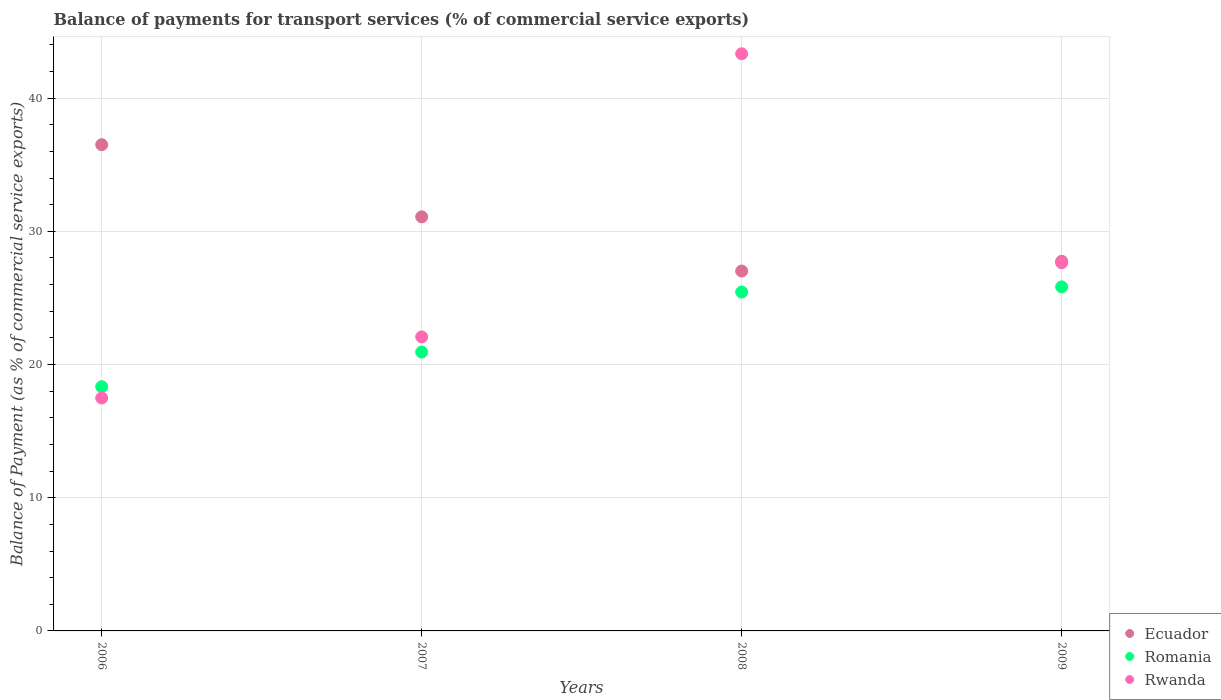Is the number of dotlines equal to the number of legend labels?
Offer a very short reply. Yes. What is the balance of payments for transport services in Rwanda in 2009?
Give a very brief answer. 27.64. Across all years, what is the maximum balance of payments for transport services in Rwanda?
Offer a very short reply. 43.33. Across all years, what is the minimum balance of payments for transport services in Ecuador?
Offer a very short reply. 27.02. What is the total balance of payments for transport services in Rwanda in the graph?
Provide a short and direct response. 110.54. What is the difference between the balance of payments for transport services in Romania in 2006 and that in 2009?
Offer a very short reply. -7.5. What is the difference between the balance of payments for transport services in Ecuador in 2006 and the balance of payments for transport services in Rwanda in 2007?
Your answer should be compact. 14.43. What is the average balance of payments for transport services in Rwanda per year?
Provide a succinct answer. 27.64. In the year 2008, what is the difference between the balance of payments for transport services in Rwanda and balance of payments for transport services in Romania?
Offer a very short reply. 17.89. In how many years, is the balance of payments for transport services in Rwanda greater than 24 %?
Your answer should be very brief. 2. What is the ratio of the balance of payments for transport services in Romania in 2007 to that in 2008?
Give a very brief answer. 0.82. Is the balance of payments for transport services in Rwanda in 2006 less than that in 2009?
Ensure brevity in your answer.  Yes. Is the difference between the balance of payments for transport services in Rwanda in 2008 and 2009 greater than the difference between the balance of payments for transport services in Romania in 2008 and 2009?
Make the answer very short. Yes. What is the difference between the highest and the second highest balance of payments for transport services in Romania?
Provide a short and direct response. 0.39. What is the difference between the highest and the lowest balance of payments for transport services in Rwanda?
Offer a very short reply. 25.84. Is the sum of the balance of payments for transport services in Rwanda in 2006 and 2007 greater than the maximum balance of payments for transport services in Romania across all years?
Provide a short and direct response. Yes. Is it the case that in every year, the sum of the balance of payments for transport services in Rwanda and balance of payments for transport services in Ecuador  is greater than the balance of payments for transport services in Romania?
Your answer should be compact. Yes. Does the balance of payments for transport services in Ecuador monotonically increase over the years?
Offer a very short reply. No. How many years are there in the graph?
Make the answer very short. 4. Are the values on the major ticks of Y-axis written in scientific E-notation?
Your answer should be very brief. No. Does the graph contain any zero values?
Your answer should be compact. No. Does the graph contain grids?
Offer a very short reply. Yes. How many legend labels are there?
Offer a very short reply. 3. What is the title of the graph?
Keep it short and to the point. Balance of payments for transport services (% of commercial service exports). What is the label or title of the X-axis?
Provide a short and direct response. Years. What is the label or title of the Y-axis?
Keep it short and to the point. Balance of Payment (as % of commercial service exports). What is the Balance of Payment (as % of commercial service exports) of Ecuador in 2006?
Your response must be concise. 36.51. What is the Balance of Payment (as % of commercial service exports) in Romania in 2006?
Your answer should be compact. 18.34. What is the Balance of Payment (as % of commercial service exports) in Rwanda in 2006?
Offer a very short reply. 17.49. What is the Balance of Payment (as % of commercial service exports) of Ecuador in 2007?
Provide a short and direct response. 31.09. What is the Balance of Payment (as % of commercial service exports) of Romania in 2007?
Ensure brevity in your answer.  20.94. What is the Balance of Payment (as % of commercial service exports) in Rwanda in 2007?
Your response must be concise. 22.08. What is the Balance of Payment (as % of commercial service exports) of Ecuador in 2008?
Provide a short and direct response. 27.02. What is the Balance of Payment (as % of commercial service exports) in Romania in 2008?
Offer a terse response. 25.44. What is the Balance of Payment (as % of commercial service exports) of Rwanda in 2008?
Provide a short and direct response. 43.33. What is the Balance of Payment (as % of commercial service exports) of Ecuador in 2009?
Your answer should be compact. 27.75. What is the Balance of Payment (as % of commercial service exports) of Romania in 2009?
Keep it short and to the point. 25.83. What is the Balance of Payment (as % of commercial service exports) of Rwanda in 2009?
Your answer should be very brief. 27.64. Across all years, what is the maximum Balance of Payment (as % of commercial service exports) in Ecuador?
Make the answer very short. 36.51. Across all years, what is the maximum Balance of Payment (as % of commercial service exports) of Romania?
Offer a terse response. 25.83. Across all years, what is the maximum Balance of Payment (as % of commercial service exports) of Rwanda?
Make the answer very short. 43.33. Across all years, what is the minimum Balance of Payment (as % of commercial service exports) in Ecuador?
Offer a very short reply. 27.02. Across all years, what is the minimum Balance of Payment (as % of commercial service exports) of Romania?
Your answer should be very brief. 18.34. Across all years, what is the minimum Balance of Payment (as % of commercial service exports) in Rwanda?
Ensure brevity in your answer.  17.49. What is the total Balance of Payment (as % of commercial service exports) in Ecuador in the graph?
Offer a very short reply. 122.37. What is the total Balance of Payment (as % of commercial service exports) in Romania in the graph?
Give a very brief answer. 90.55. What is the total Balance of Payment (as % of commercial service exports) in Rwanda in the graph?
Your answer should be compact. 110.54. What is the difference between the Balance of Payment (as % of commercial service exports) in Ecuador in 2006 and that in 2007?
Provide a succinct answer. 5.42. What is the difference between the Balance of Payment (as % of commercial service exports) in Romania in 2006 and that in 2007?
Offer a terse response. -2.6. What is the difference between the Balance of Payment (as % of commercial service exports) of Rwanda in 2006 and that in 2007?
Your response must be concise. -4.59. What is the difference between the Balance of Payment (as % of commercial service exports) of Ecuador in 2006 and that in 2008?
Your answer should be compact. 9.49. What is the difference between the Balance of Payment (as % of commercial service exports) in Romania in 2006 and that in 2008?
Your answer should be very brief. -7.11. What is the difference between the Balance of Payment (as % of commercial service exports) in Rwanda in 2006 and that in 2008?
Keep it short and to the point. -25.84. What is the difference between the Balance of Payment (as % of commercial service exports) of Ecuador in 2006 and that in 2009?
Your answer should be very brief. 8.76. What is the difference between the Balance of Payment (as % of commercial service exports) in Romania in 2006 and that in 2009?
Offer a very short reply. -7.5. What is the difference between the Balance of Payment (as % of commercial service exports) in Rwanda in 2006 and that in 2009?
Your answer should be very brief. -10.15. What is the difference between the Balance of Payment (as % of commercial service exports) of Ecuador in 2007 and that in 2008?
Keep it short and to the point. 4.07. What is the difference between the Balance of Payment (as % of commercial service exports) in Romania in 2007 and that in 2008?
Offer a terse response. -4.5. What is the difference between the Balance of Payment (as % of commercial service exports) of Rwanda in 2007 and that in 2008?
Your answer should be very brief. -21.26. What is the difference between the Balance of Payment (as % of commercial service exports) in Ecuador in 2007 and that in 2009?
Keep it short and to the point. 3.34. What is the difference between the Balance of Payment (as % of commercial service exports) of Romania in 2007 and that in 2009?
Keep it short and to the point. -4.9. What is the difference between the Balance of Payment (as % of commercial service exports) of Rwanda in 2007 and that in 2009?
Provide a short and direct response. -5.57. What is the difference between the Balance of Payment (as % of commercial service exports) of Ecuador in 2008 and that in 2009?
Offer a very short reply. -0.73. What is the difference between the Balance of Payment (as % of commercial service exports) in Romania in 2008 and that in 2009?
Provide a short and direct response. -0.39. What is the difference between the Balance of Payment (as % of commercial service exports) in Rwanda in 2008 and that in 2009?
Keep it short and to the point. 15.69. What is the difference between the Balance of Payment (as % of commercial service exports) of Ecuador in 2006 and the Balance of Payment (as % of commercial service exports) of Romania in 2007?
Your answer should be compact. 15.57. What is the difference between the Balance of Payment (as % of commercial service exports) in Ecuador in 2006 and the Balance of Payment (as % of commercial service exports) in Rwanda in 2007?
Offer a very short reply. 14.43. What is the difference between the Balance of Payment (as % of commercial service exports) in Romania in 2006 and the Balance of Payment (as % of commercial service exports) in Rwanda in 2007?
Offer a very short reply. -3.74. What is the difference between the Balance of Payment (as % of commercial service exports) of Ecuador in 2006 and the Balance of Payment (as % of commercial service exports) of Romania in 2008?
Offer a terse response. 11.07. What is the difference between the Balance of Payment (as % of commercial service exports) of Ecuador in 2006 and the Balance of Payment (as % of commercial service exports) of Rwanda in 2008?
Offer a terse response. -6.82. What is the difference between the Balance of Payment (as % of commercial service exports) of Romania in 2006 and the Balance of Payment (as % of commercial service exports) of Rwanda in 2008?
Your answer should be compact. -25. What is the difference between the Balance of Payment (as % of commercial service exports) in Ecuador in 2006 and the Balance of Payment (as % of commercial service exports) in Romania in 2009?
Ensure brevity in your answer.  10.67. What is the difference between the Balance of Payment (as % of commercial service exports) in Ecuador in 2006 and the Balance of Payment (as % of commercial service exports) in Rwanda in 2009?
Offer a terse response. 8.87. What is the difference between the Balance of Payment (as % of commercial service exports) in Romania in 2006 and the Balance of Payment (as % of commercial service exports) in Rwanda in 2009?
Keep it short and to the point. -9.31. What is the difference between the Balance of Payment (as % of commercial service exports) in Ecuador in 2007 and the Balance of Payment (as % of commercial service exports) in Romania in 2008?
Provide a short and direct response. 5.65. What is the difference between the Balance of Payment (as % of commercial service exports) of Ecuador in 2007 and the Balance of Payment (as % of commercial service exports) of Rwanda in 2008?
Your response must be concise. -12.24. What is the difference between the Balance of Payment (as % of commercial service exports) in Romania in 2007 and the Balance of Payment (as % of commercial service exports) in Rwanda in 2008?
Ensure brevity in your answer.  -22.39. What is the difference between the Balance of Payment (as % of commercial service exports) in Ecuador in 2007 and the Balance of Payment (as % of commercial service exports) in Romania in 2009?
Your answer should be very brief. 5.26. What is the difference between the Balance of Payment (as % of commercial service exports) of Ecuador in 2007 and the Balance of Payment (as % of commercial service exports) of Rwanda in 2009?
Your response must be concise. 3.45. What is the difference between the Balance of Payment (as % of commercial service exports) of Romania in 2007 and the Balance of Payment (as % of commercial service exports) of Rwanda in 2009?
Offer a very short reply. -6.7. What is the difference between the Balance of Payment (as % of commercial service exports) in Ecuador in 2008 and the Balance of Payment (as % of commercial service exports) in Romania in 2009?
Your response must be concise. 1.19. What is the difference between the Balance of Payment (as % of commercial service exports) of Ecuador in 2008 and the Balance of Payment (as % of commercial service exports) of Rwanda in 2009?
Your answer should be very brief. -0.62. What is the difference between the Balance of Payment (as % of commercial service exports) of Romania in 2008 and the Balance of Payment (as % of commercial service exports) of Rwanda in 2009?
Give a very brief answer. -2.2. What is the average Balance of Payment (as % of commercial service exports) of Ecuador per year?
Offer a very short reply. 30.59. What is the average Balance of Payment (as % of commercial service exports) in Romania per year?
Give a very brief answer. 22.64. What is the average Balance of Payment (as % of commercial service exports) of Rwanda per year?
Your answer should be compact. 27.64. In the year 2006, what is the difference between the Balance of Payment (as % of commercial service exports) of Ecuador and Balance of Payment (as % of commercial service exports) of Romania?
Provide a succinct answer. 18.17. In the year 2006, what is the difference between the Balance of Payment (as % of commercial service exports) in Ecuador and Balance of Payment (as % of commercial service exports) in Rwanda?
Offer a very short reply. 19.02. In the year 2006, what is the difference between the Balance of Payment (as % of commercial service exports) of Romania and Balance of Payment (as % of commercial service exports) of Rwanda?
Offer a very short reply. 0.85. In the year 2007, what is the difference between the Balance of Payment (as % of commercial service exports) of Ecuador and Balance of Payment (as % of commercial service exports) of Romania?
Keep it short and to the point. 10.15. In the year 2007, what is the difference between the Balance of Payment (as % of commercial service exports) of Ecuador and Balance of Payment (as % of commercial service exports) of Rwanda?
Make the answer very short. 9.01. In the year 2007, what is the difference between the Balance of Payment (as % of commercial service exports) of Romania and Balance of Payment (as % of commercial service exports) of Rwanda?
Your answer should be very brief. -1.14. In the year 2008, what is the difference between the Balance of Payment (as % of commercial service exports) in Ecuador and Balance of Payment (as % of commercial service exports) in Romania?
Your answer should be very brief. 1.58. In the year 2008, what is the difference between the Balance of Payment (as % of commercial service exports) in Ecuador and Balance of Payment (as % of commercial service exports) in Rwanda?
Your answer should be compact. -16.31. In the year 2008, what is the difference between the Balance of Payment (as % of commercial service exports) in Romania and Balance of Payment (as % of commercial service exports) in Rwanda?
Keep it short and to the point. -17.89. In the year 2009, what is the difference between the Balance of Payment (as % of commercial service exports) of Ecuador and Balance of Payment (as % of commercial service exports) of Romania?
Provide a succinct answer. 1.92. In the year 2009, what is the difference between the Balance of Payment (as % of commercial service exports) of Ecuador and Balance of Payment (as % of commercial service exports) of Rwanda?
Make the answer very short. 0.11. In the year 2009, what is the difference between the Balance of Payment (as % of commercial service exports) in Romania and Balance of Payment (as % of commercial service exports) in Rwanda?
Your answer should be very brief. -1.81. What is the ratio of the Balance of Payment (as % of commercial service exports) in Ecuador in 2006 to that in 2007?
Offer a very short reply. 1.17. What is the ratio of the Balance of Payment (as % of commercial service exports) of Romania in 2006 to that in 2007?
Your response must be concise. 0.88. What is the ratio of the Balance of Payment (as % of commercial service exports) in Rwanda in 2006 to that in 2007?
Offer a terse response. 0.79. What is the ratio of the Balance of Payment (as % of commercial service exports) of Ecuador in 2006 to that in 2008?
Your answer should be compact. 1.35. What is the ratio of the Balance of Payment (as % of commercial service exports) of Romania in 2006 to that in 2008?
Ensure brevity in your answer.  0.72. What is the ratio of the Balance of Payment (as % of commercial service exports) in Rwanda in 2006 to that in 2008?
Ensure brevity in your answer.  0.4. What is the ratio of the Balance of Payment (as % of commercial service exports) in Ecuador in 2006 to that in 2009?
Provide a succinct answer. 1.32. What is the ratio of the Balance of Payment (as % of commercial service exports) of Romania in 2006 to that in 2009?
Ensure brevity in your answer.  0.71. What is the ratio of the Balance of Payment (as % of commercial service exports) in Rwanda in 2006 to that in 2009?
Provide a short and direct response. 0.63. What is the ratio of the Balance of Payment (as % of commercial service exports) of Ecuador in 2007 to that in 2008?
Make the answer very short. 1.15. What is the ratio of the Balance of Payment (as % of commercial service exports) of Romania in 2007 to that in 2008?
Provide a short and direct response. 0.82. What is the ratio of the Balance of Payment (as % of commercial service exports) in Rwanda in 2007 to that in 2008?
Keep it short and to the point. 0.51. What is the ratio of the Balance of Payment (as % of commercial service exports) of Ecuador in 2007 to that in 2009?
Give a very brief answer. 1.12. What is the ratio of the Balance of Payment (as % of commercial service exports) of Romania in 2007 to that in 2009?
Provide a succinct answer. 0.81. What is the ratio of the Balance of Payment (as % of commercial service exports) in Rwanda in 2007 to that in 2009?
Provide a short and direct response. 0.8. What is the ratio of the Balance of Payment (as % of commercial service exports) of Ecuador in 2008 to that in 2009?
Keep it short and to the point. 0.97. What is the ratio of the Balance of Payment (as % of commercial service exports) of Romania in 2008 to that in 2009?
Provide a short and direct response. 0.98. What is the ratio of the Balance of Payment (as % of commercial service exports) of Rwanda in 2008 to that in 2009?
Offer a terse response. 1.57. What is the difference between the highest and the second highest Balance of Payment (as % of commercial service exports) of Ecuador?
Keep it short and to the point. 5.42. What is the difference between the highest and the second highest Balance of Payment (as % of commercial service exports) in Romania?
Provide a short and direct response. 0.39. What is the difference between the highest and the second highest Balance of Payment (as % of commercial service exports) in Rwanda?
Offer a very short reply. 15.69. What is the difference between the highest and the lowest Balance of Payment (as % of commercial service exports) of Ecuador?
Offer a terse response. 9.49. What is the difference between the highest and the lowest Balance of Payment (as % of commercial service exports) in Romania?
Keep it short and to the point. 7.5. What is the difference between the highest and the lowest Balance of Payment (as % of commercial service exports) of Rwanda?
Ensure brevity in your answer.  25.84. 